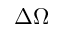<formula> <loc_0><loc_0><loc_500><loc_500>\Delta \Omega</formula> 